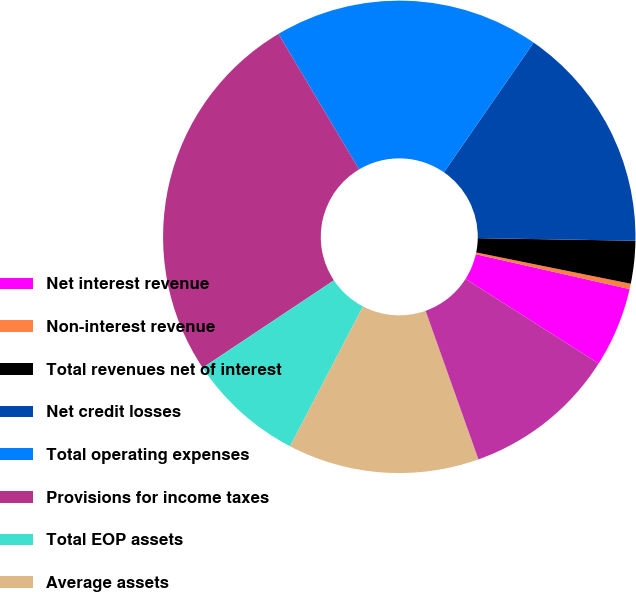Convert chart. <chart><loc_0><loc_0><loc_500><loc_500><pie_chart><fcel>Net interest revenue<fcel>Non-interest revenue<fcel>Total revenues net of interest<fcel>Net credit losses<fcel>Total operating expenses<fcel>Provisions for income taxes<fcel>Total EOP assets<fcel>Average assets<fcel>Total EOP deposits<nl><fcel>5.46%<fcel>0.37%<fcel>2.92%<fcel>15.63%<fcel>18.18%<fcel>25.8%<fcel>8.0%<fcel>13.09%<fcel>10.55%<nl></chart> 